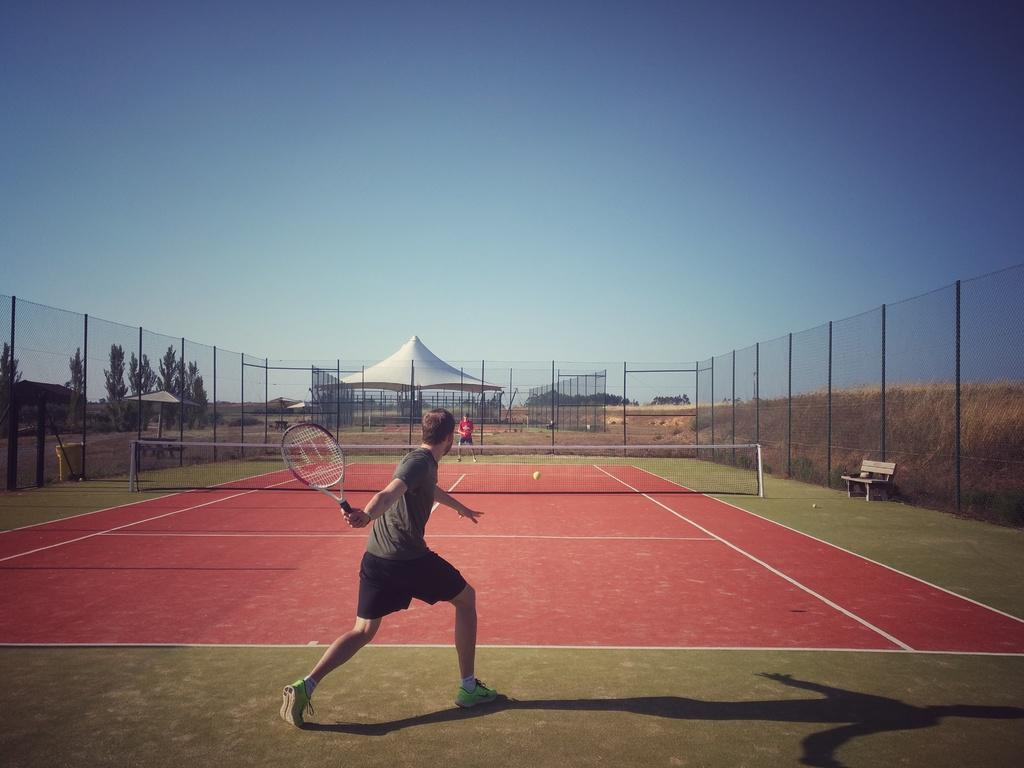What can be seen at the top of the image? The sky is visible at the top of the image. What type of structure is present in the image? There is a tent in the image. What is covering the ground in the image? There is a mesh around the ground in the image. What type of seating is available in the image? There is a bench in the image. What activity are the two people engaged in? Two players are playing badminton in the image. How many horses are present in the image? There are no horses present in the image. What type of building can be seen in the background of the image? There is no building visible in the image; it primarily features a tent and outdoor elements. 